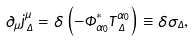Convert formula to latex. <formula><loc_0><loc_0><loc_500><loc_500>\partial _ { \mu } j _ { \, \Delta } ^ { \mu } = \delta \left ( - \Phi _ { \alpha _ { 0 } } ^ { * } T _ { \, \Delta } ^ { \alpha _ { 0 } } \right ) \equiv \delta \sigma _ { \Delta } ,</formula> 